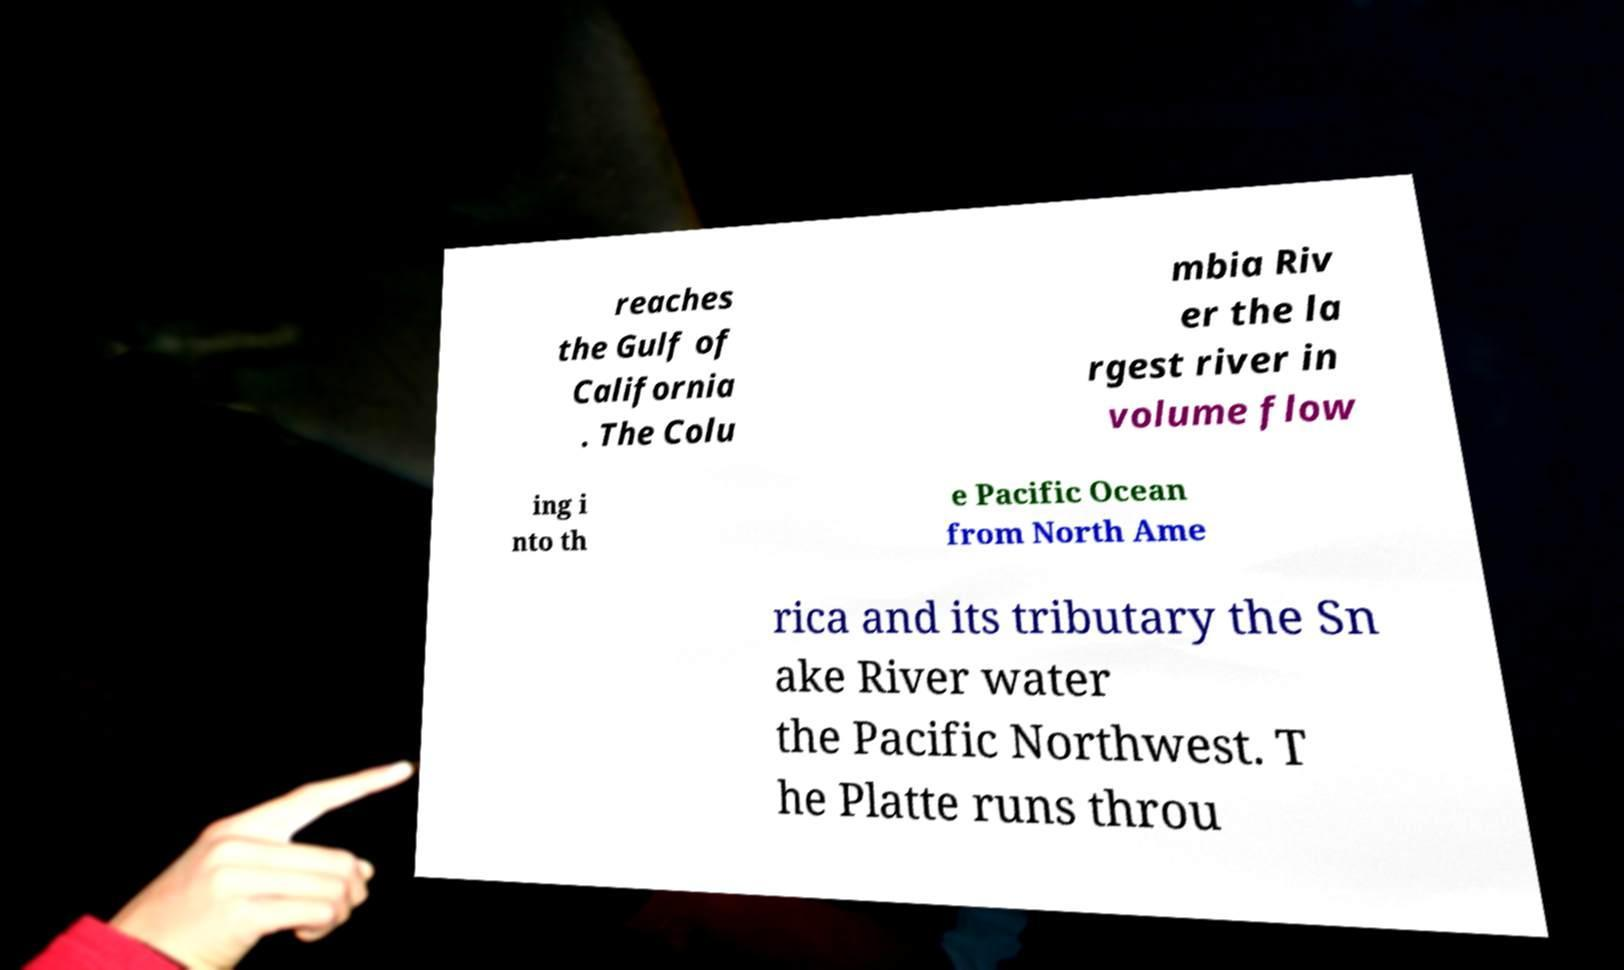Could you assist in decoding the text presented in this image and type it out clearly? reaches the Gulf of California . The Colu mbia Riv er the la rgest river in volume flow ing i nto th e Pacific Ocean from North Ame rica and its tributary the Sn ake River water the Pacific Northwest. T he Platte runs throu 